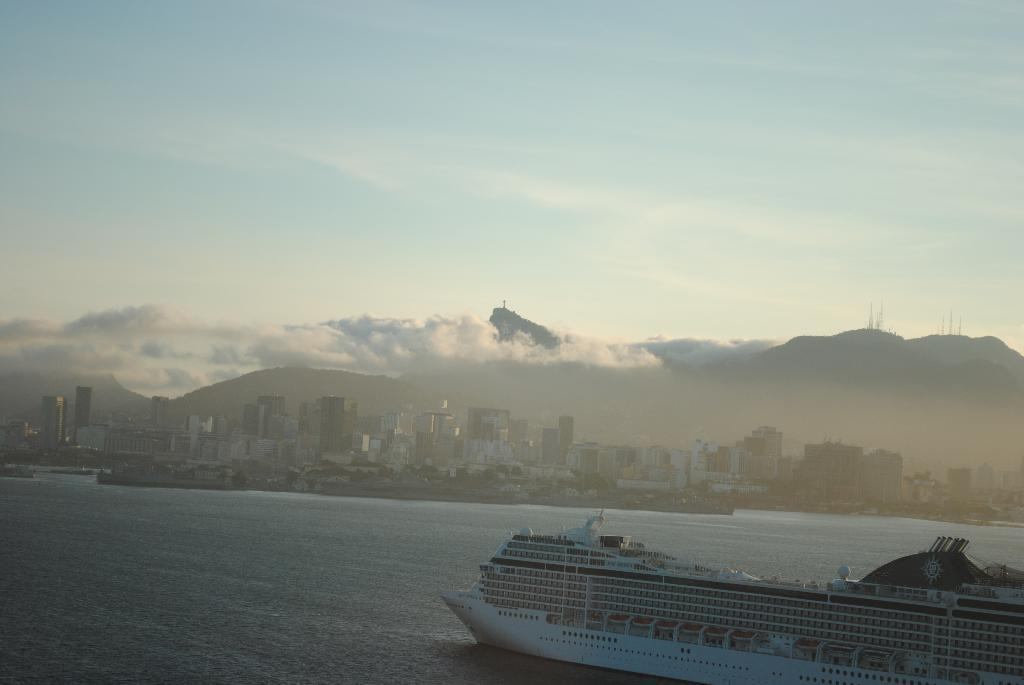What is the main subject of the image? There is a ship on the surface of water in the image. What can be seen in the background of the image? There are buildings and mountains in the background of the image. What is visible at the top of the image? The sky is visible at the top of the image. How many kites are flying in the sky in the image? There are no kites visible in the image; only the ship, water, buildings, mountains, and sky are present. 